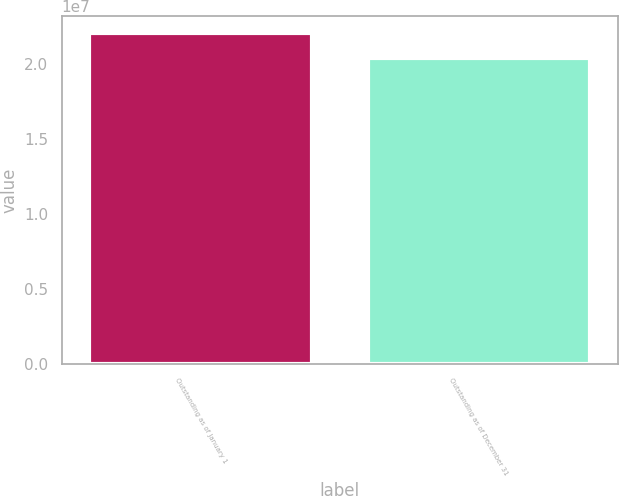Convert chart. <chart><loc_0><loc_0><loc_500><loc_500><bar_chart><fcel>Outstanding as of January 1<fcel>Outstanding as of December 31<nl><fcel>2.2115e+07<fcel>2.0403e+07<nl></chart> 